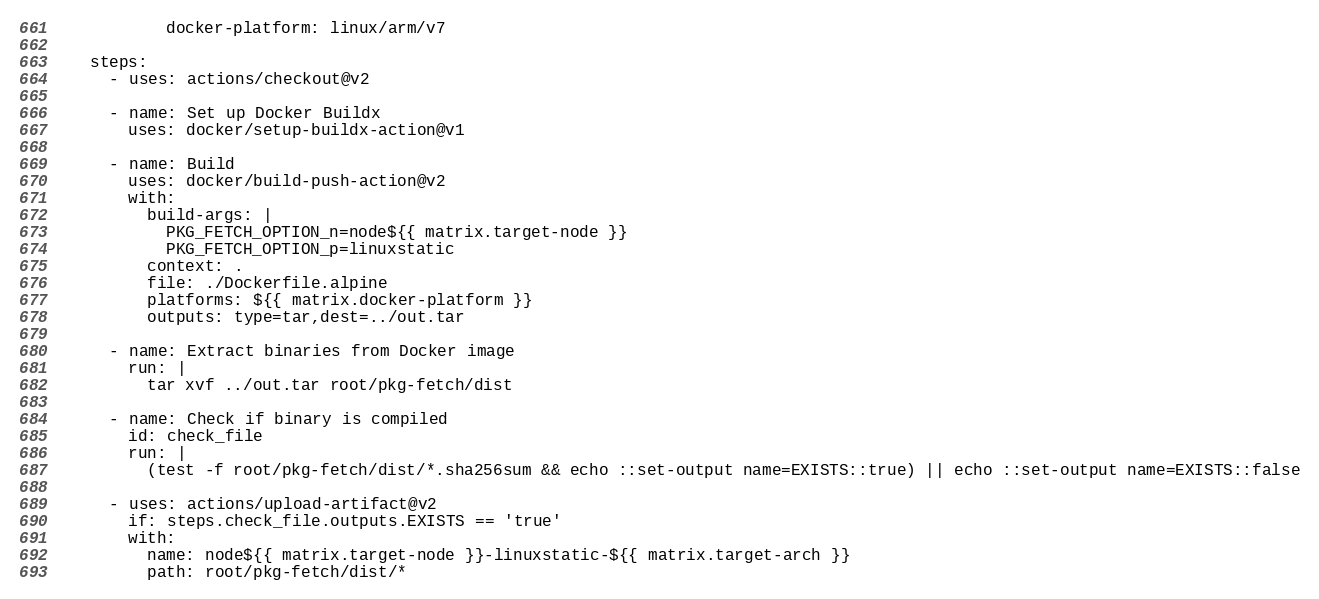<code> <loc_0><loc_0><loc_500><loc_500><_YAML_>            docker-platform: linux/arm/v7

    steps:
      - uses: actions/checkout@v2

      - name: Set up Docker Buildx
        uses: docker/setup-buildx-action@v1

      - name: Build
        uses: docker/build-push-action@v2
        with:
          build-args: |
            PKG_FETCH_OPTION_n=node${{ matrix.target-node }}
            PKG_FETCH_OPTION_p=linuxstatic
          context: .
          file: ./Dockerfile.alpine
          platforms: ${{ matrix.docker-platform }}
          outputs: type=tar,dest=../out.tar

      - name: Extract binaries from Docker image
        run: |
          tar xvf ../out.tar root/pkg-fetch/dist

      - name: Check if binary is compiled
        id: check_file
        run: |
          (test -f root/pkg-fetch/dist/*.sha256sum && echo ::set-output name=EXISTS::true) || echo ::set-output name=EXISTS::false

      - uses: actions/upload-artifact@v2
        if: steps.check_file.outputs.EXISTS == 'true'
        with:
          name: node${{ matrix.target-node }}-linuxstatic-${{ matrix.target-arch }}
          path: root/pkg-fetch/dist/*
</code> 